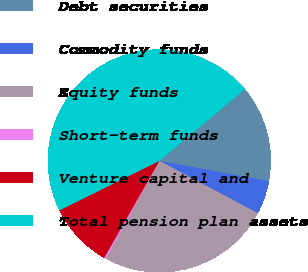Convert chart. <chart><loc_0><loc_0><loc_500><loc_500><pie_chart><fcel>Debt securities<fcel>Commodity funds<fcel>Equity funds<fcel>Short-term funds<fcel>Venture capital and<fcel>Total pension plan assets<nl><fcel>14.04%<fcel>4.85%<fcel>25.21%<fcel>0.26%<fcel>9.45%<fcel>46.19%<nl></chart> 